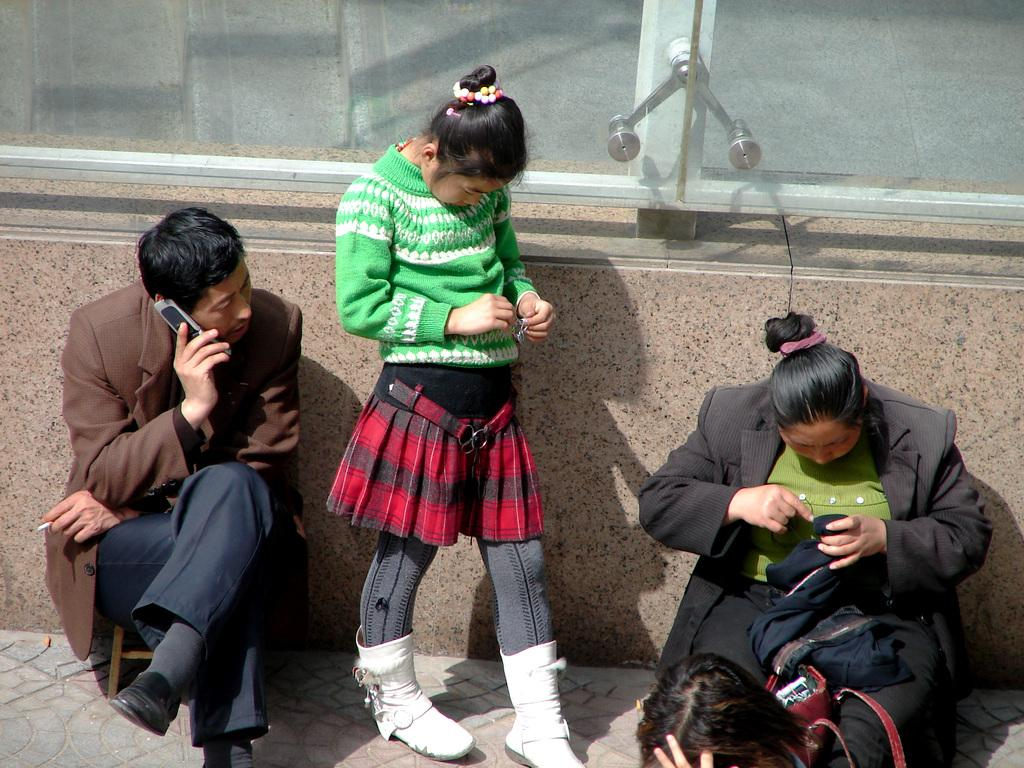How many people are in the image? There are three persons in the image. Can you describe the man on the left side? The man on the left side is speaking on the phone. What about the woman on the right side? The woman on the right side is doing something. What type of sweater is the afterthought wearing in the image? There is no afterthought or sweater present in the image. Can you tell me where the scissors are located in the image? There are no scissors present in the image. 